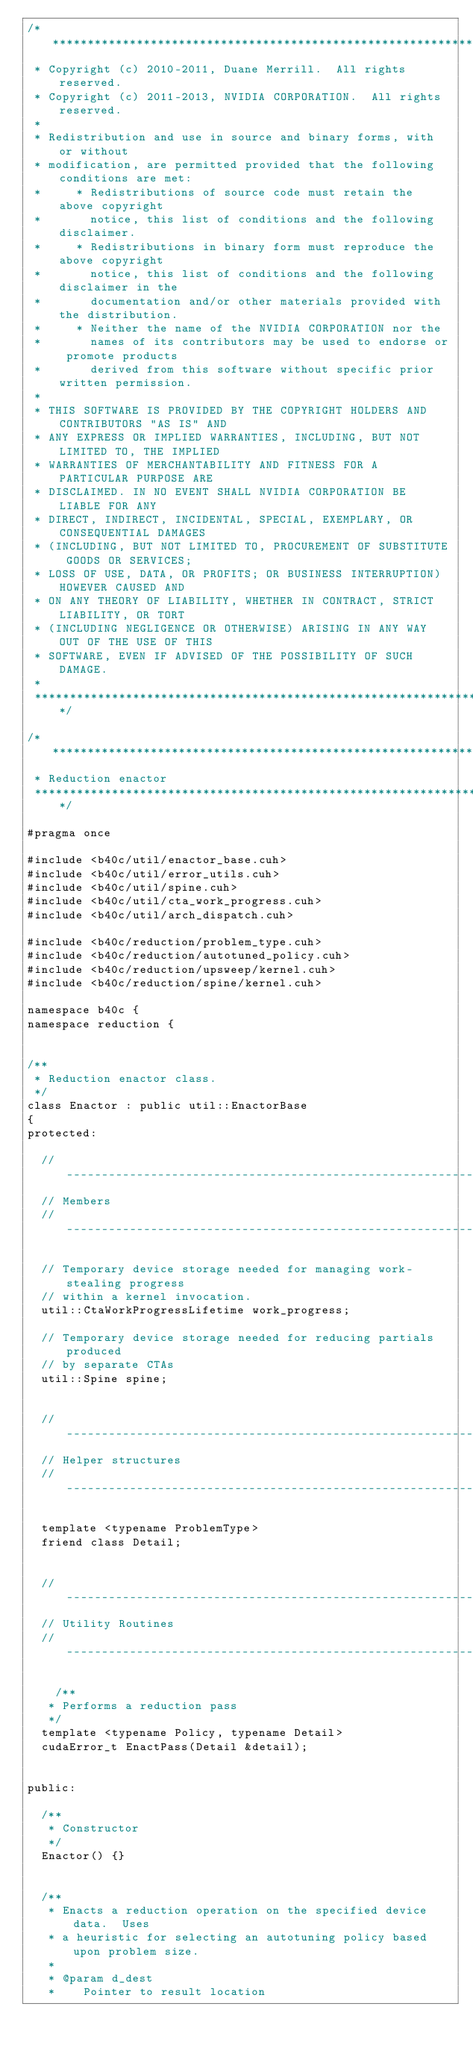<code> <loc_0><loc_0><loc_500><loc_500><_Cuda_>/******************************************************************************
 * Copyright (c) 2010-2011, Duane Merrill.  All rights reserved.
 * Copyright (c) 2011-2013, NVIDIA CORPORATION.  All rights reserved.
 * 
 * Redistribution and use in source and binary forms, with or without
 * modification, are permitted provided that the following conditions are met:
 *     * Redistributions of source code must retain the above copyright
 *       notice, this list of conditions and the following disclaimer.
 *     * Redistributions in binary form must reproduce the above copyright
 *       notice, this list of conditions and the following disclaimer in the
 *       documentation and/or other materials provided with the distribution.
 *     * Neither the name of the NVIDIA CORPORATION nor the
 *       names of its contributors may be used to endorse or promote products
 *       derived from this software without specific prior written permission.
 * 
 * THIS SOFTWARE IS PROVIDED BY THE COPYRIGHT HOLDERS AND CONTRIBUTORS "AS IS" AND
 * ANY EXPRESS OR IMPLIED WARRANTIES, INCLUDING, BUT NOT LIMITED TO, THE IMPLIED
 * WARRANTIES OF MERCHANTABILITY AND FITNESS FOR A PARTICULAR PURPOSE ARE
 * DISCLAIMED. IN NO EVENT SHALL NVIDIA CORPORATION BE LIABLE FOR ANY
 * DIRECT, INDIRECT, INCIDENTAL, SPECIAL, EXEMPLARY, OR CONSEQUENTIAL DAMAGES
 * (INCLUDING, BUT NOT LIMITED TO, PROCUREMENT OF SUBSTITUTE GOODS OR SERVICES;
 * LOSS OF USE, DATA, OR PROFITS; OR BUSINESS INTERRUPTION) HOWEVER CAUSED AND
 * ON ANY THEORY OF LIABILITY, WHETHER IN CONTRACT, STRICT LIABILITY, OR TORT
 * (INCLUDING NEGLIGENCE OR OTHERWISE) ARISING IN ANY WAY OUT OF THE USE OF THIS
 * SOFTWARE, EVEN IF ADVISED OF THE POSSIBILITY OF SUCH DAMAGE.
 *
 ******************************************************************************/

/******************************************************************************
 * Reduction enactor
 ******************************************************************************/

#pragma once

#include <b40c/util/enactor_base.cuh>
#include <b40c/util/error_utils.cuh>
#include <b40c/util/spine.cuh>
#include <b40c/util/cta_work_progress.cuh>
#include <b40c/util/arch_dispatch.cuh>

#include <b40c/reduction/problem_type.cuh>
#include <b40c/reduction/autotuned_policy.cuh>
#include <b40c/reduction/upsweep/kernel.cuh>
#include <b40c/reduction/spine/kernel.cuh>

namespace b40c {
namespace reduction {


/**
 * Reduction enactor class.
 */
class Enactor : public util::EnactorBase
{
protected:

	//---------------------------------------------------------------------
	// Members
	//---------------------------------------------------------------------

	// Temporary device storage needed for managing work-stealing progress
	// within a kernel invocation.
	util::CtaWorkProgressLifetime work_progress;

	// Temporary device storage needed for reducing partials produced
	// by separate CTAs
	util::Spine spine;


	//-----------------------------------------------------------------------------
	// Helper structures
	//-----------------------------------------------------------------------------

	template <typename ProblemType>
	friend class Detail;


	//-----------------------------------------------------------------------------
	// Utility Routines
	//-----------------------------------------------------------------------------

    /**
	 * Performs a reduction pass
	 */
	template <typename Policy, typename Detail>
	cudaError_t EnactPass(Detail &detail);


public:

	/**
	 * Constructor
	 */
	Enactor() {}


	/**
	 * Enacts a reduction operation on the specified device data.  Uses
	 * a heuristic for selecting an autotuning policy based upon problem size.
	 *
	 * @param d_dest
	 * 		Pointer to result location</code> 